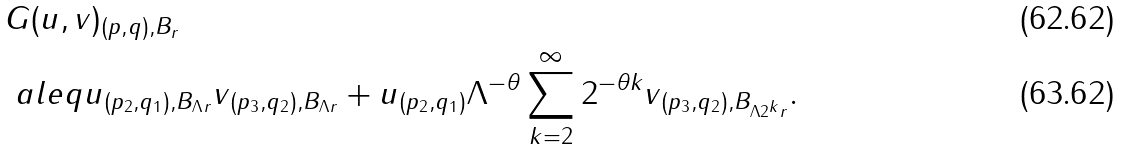Convert formula to latex. <formula><loc_0><loc_0><loc_500><loc_500>& \| G ( u , v ) \| _ { ( p , q ) , B _ { r } } \\ & \ a l e q \| u \| _ { ( p _ { 2 } , q _ { 1 } ) , B _ { \Lambda r } } \| v \| _ { ( p _ { 3 } , q _ { 2 } ) , B _ { \Lambda r } } + \| u \| _ { ( p _ { 2 } , q _ { 1 } ) } \Lambda ^ { - \theta } \sum _ { k = 2 } ^ { \infty } 2 ^ { - \theta k } \| v \| _ { ( p _ { 3 } , q _ { 2 } ) , B _ { \Lambda 2 ^ { k } r } } .</formula> 